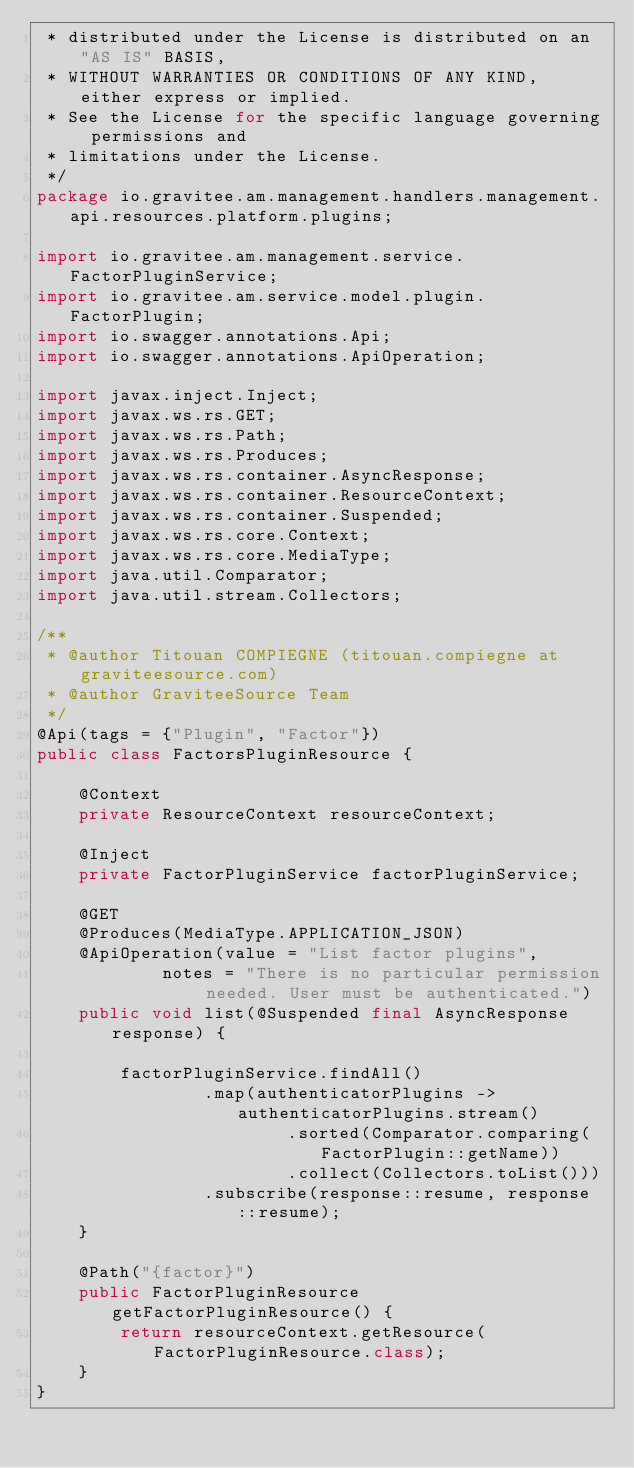<code> <loc_0><loc_0><loc_500><loc_500><_Java_> * distributed under the License is distributed on an "AS IS" BASIS,
 * WITHOUT WARRANTIES OR CONDITIONS OF ANY KIND, either express or implied.
 * See the License for the specific language governing permissions and
 * limitations under the License.
 */
package io.gravitee.am.management.handlers.management.api.resources.platform.plugins;

import io.gravitee.am.management.service.FactorPluginService;
import io.gravitee.am.service.model.plugin.FactorPlugin;
import io.swagger.annotations.Api;
import io.swagger.annotations.ApiOperation;

import javax.inject.Inject;
import javax.ws.rs.GET;
import javax.ws.rs.Path;
import javax.ws.rs.Produces;
import javax.ws.rs.container.AsyncResponse;
import javax.ws.rs.container.ResourceContext;
import javax.ws.rs.container.Suspended;
import javax.ws.rs.core.Context;
import javax.ws.rs.core.MediaType;
import java.util.Comparator;
import java.util.stream.Collectors;

/**
 * @author Titouan COMPIEGNE (titouan.compiegne at graviteesource.com)
 * @author GraviteeSource Team
 */
@Api(tags = {"Plugin", "Factor"})
public class FactorsPluginResource {

    @Context
    private ResourceContext resourceContext;

    @Inject
    private FactorPluginService factorPluginService;

    @GET
    @Produces(MediaType.APPLICATION_JSON)
    @ApiOperation(value = "List factor plugins",
            notes = "There is no particular permission needed. User must be authenticated.")
    public void list(@Suspended final AsyncResponse response) {

        factorPluginService.findAll()
                .map(authenticatorPlugins -> authenticatorPlugins.stream()
                        .sorted(Comparator.comparing(FactorPlugin::getName))
                        .collect(Collectors.toList()))
                .subscribe(response::resume, response::resume);
    }

    @Path("{factor}")
    public FactorPluginResource getFactorPluginResource() {
        return resourceContext.getResource(FactorPluginResource.class);
    }
}</code> 